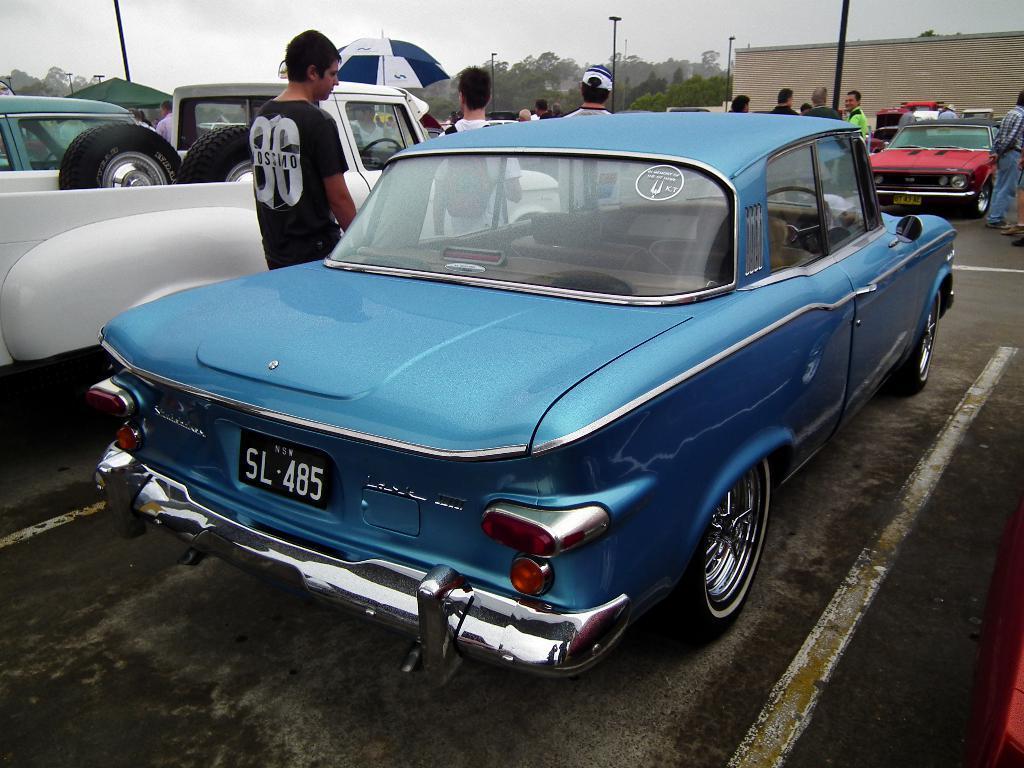In one or two sentences, can you explain what this image depicts? In this image I can see few vehicles on the road. In front the vehicle is in blue color, background I can see few persons standing, few light poles, trees in green color and a green color tent, and the sky is in blue color. 